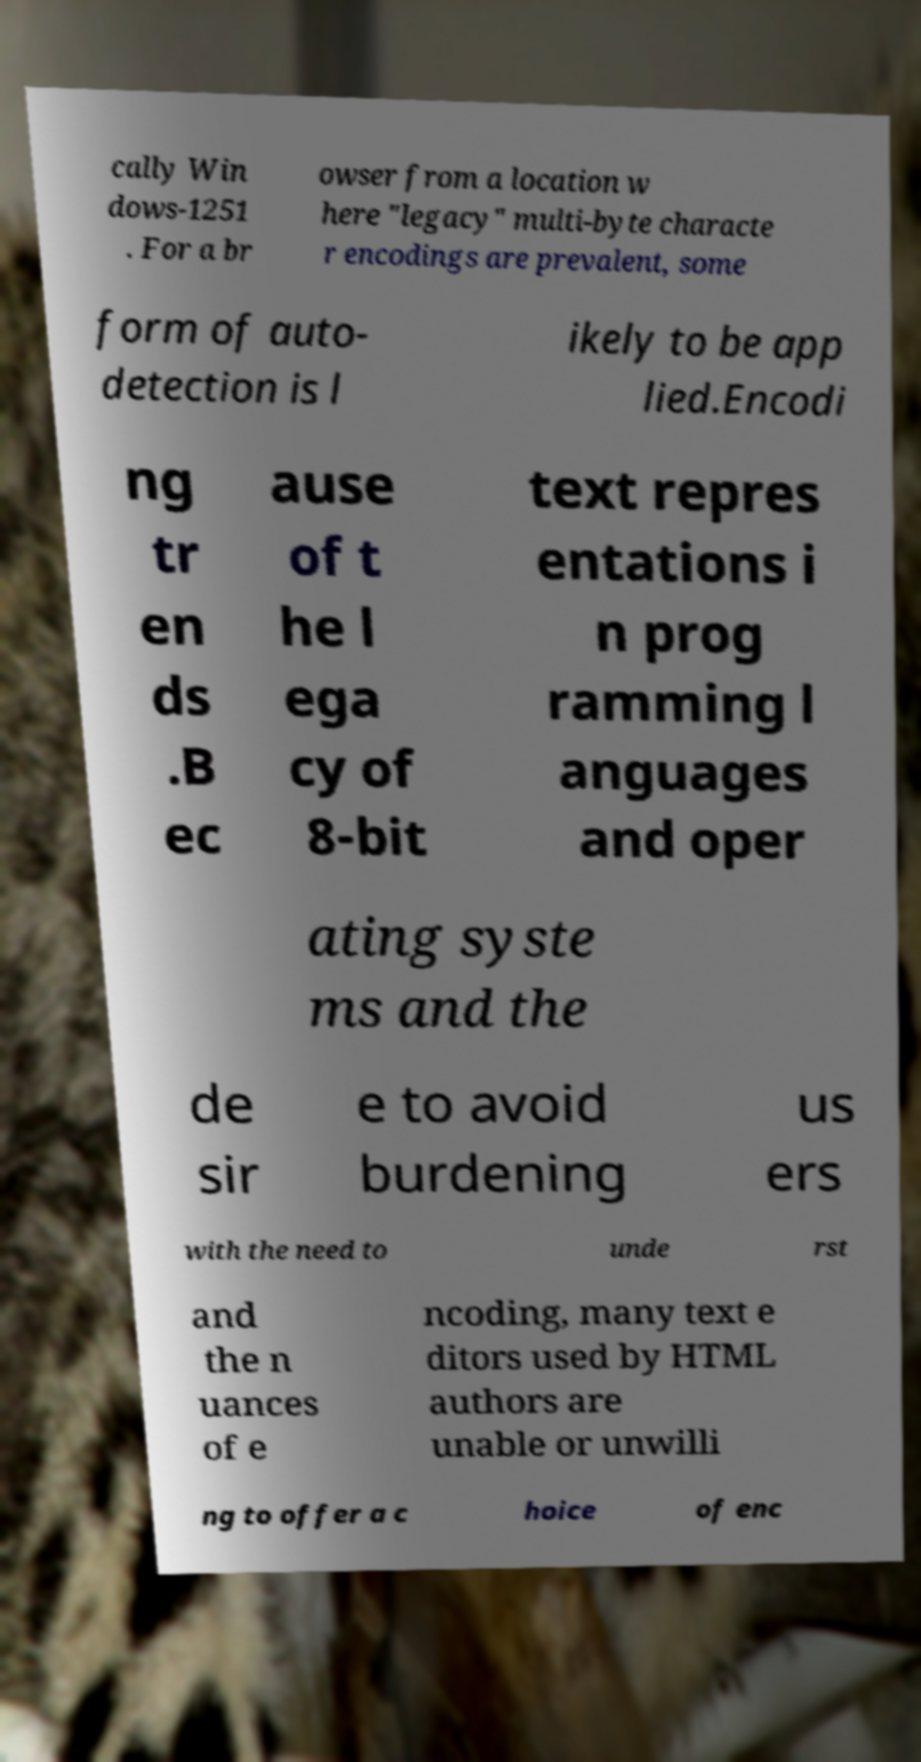Please read and relay the text visible in this image. What does it say? cally Win dows-1251 . For a br owser from a location w here "legacy" multi-byte characte r encodings are prevalent, some form of auto- detection is l ikely to be app lied.Encodi ng tr en ds .B ec ause of t he l ega cy of 8-bit text repres entations i n prog ramming l anguages and oper ating syste ms and the de sir e to avoid burdening us ers with the need to unde rst and the n uances of e ncoding, many text e ditors used by HTML authors are unable or unwilli ng to offer a c hoice of enc 